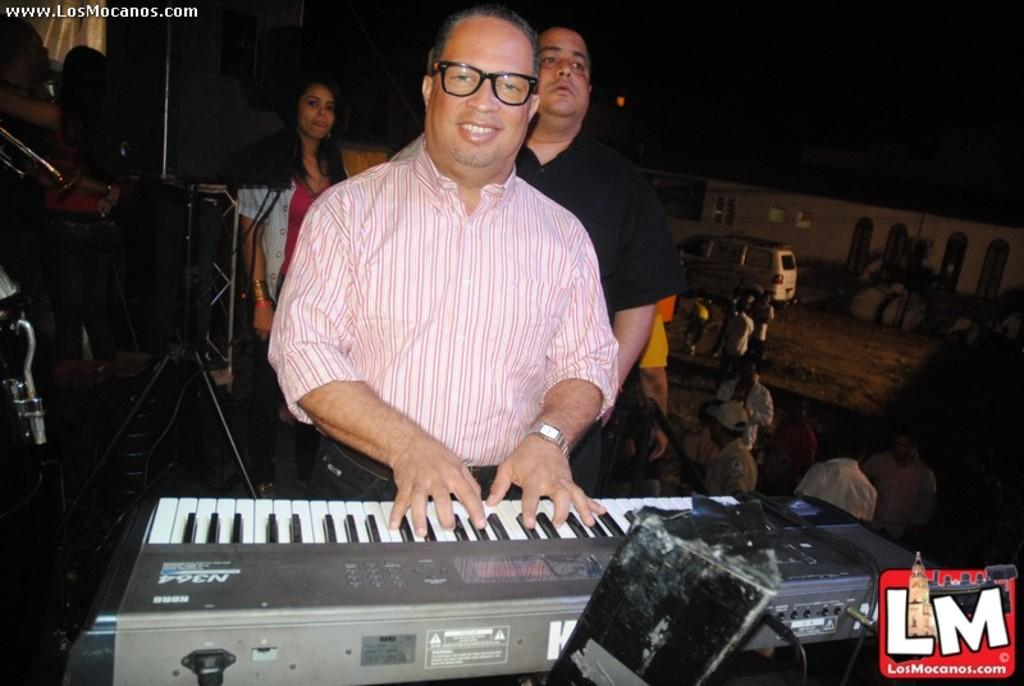What is the man in the image doing? The man is playing a piano. What is the man's facial expression in the image? The man is smiling. Can you describe the people behind the man? There is a person and a woman behind the man. What else can be seen in the image? There is a vehicle and other persons standing in the image. What type of cork can be seen in the image? There is no cork present in the image. What idea does the man have while playing the piano in the image? The image does not provide information about the man's ideas while playing the piano. 